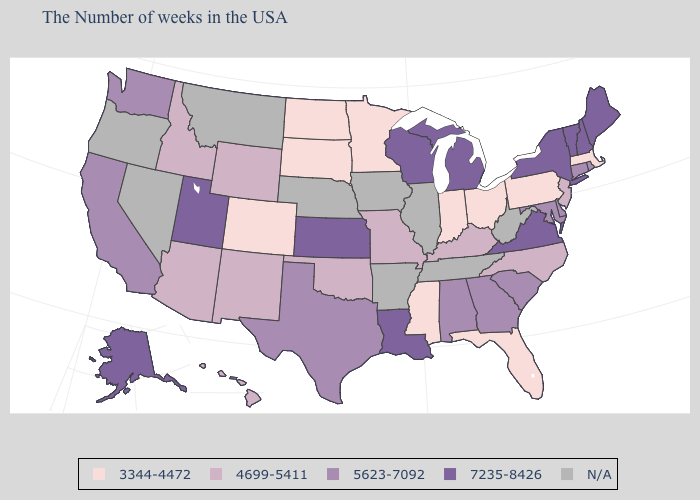Does the map have missing data?
Give a very brief answer. Yes. What is the lowest value in the MidWest?
Write a very short answer. 3344-4472. What is the highest value in states that border Virginia?
Answer briefly. 5623-7092. What is the value of Wyoming?
Short answer required. 4699-5411. Name the states that have a value in the range 5623-7092?
Write a very short answer. Rhode Island, Connecticut, Delaware, Maryland, South Carolina, Georgia, Alabama, Texas, California, Washington. What is the lowest value in the Northeast?
Give a very brief answer. 3344-4472. Among the states that border Delaware , which have the lowest value?
Quick response, please. Pennsylvania. What is the lowest value in the USA?
Be succinct. 3344-4472. Does New York have the highest value in the USA?
Give a very brief answer. Yes. Does Massachusetts have the lowest value in the USA?
Answer briefly. Yes. What is the value of North Dakota?
Concise answer only. 3344-4472. Name the states that have a value in the range 5623-7092?
Give a very brief answer. Rhode Island, Connecticut, Delaware, Maryland, South Carolina, Georgia, Alabama, Texas, California, Washington. Does Maine have the lowest value in the Northeast?
Write a very short answer. No. 